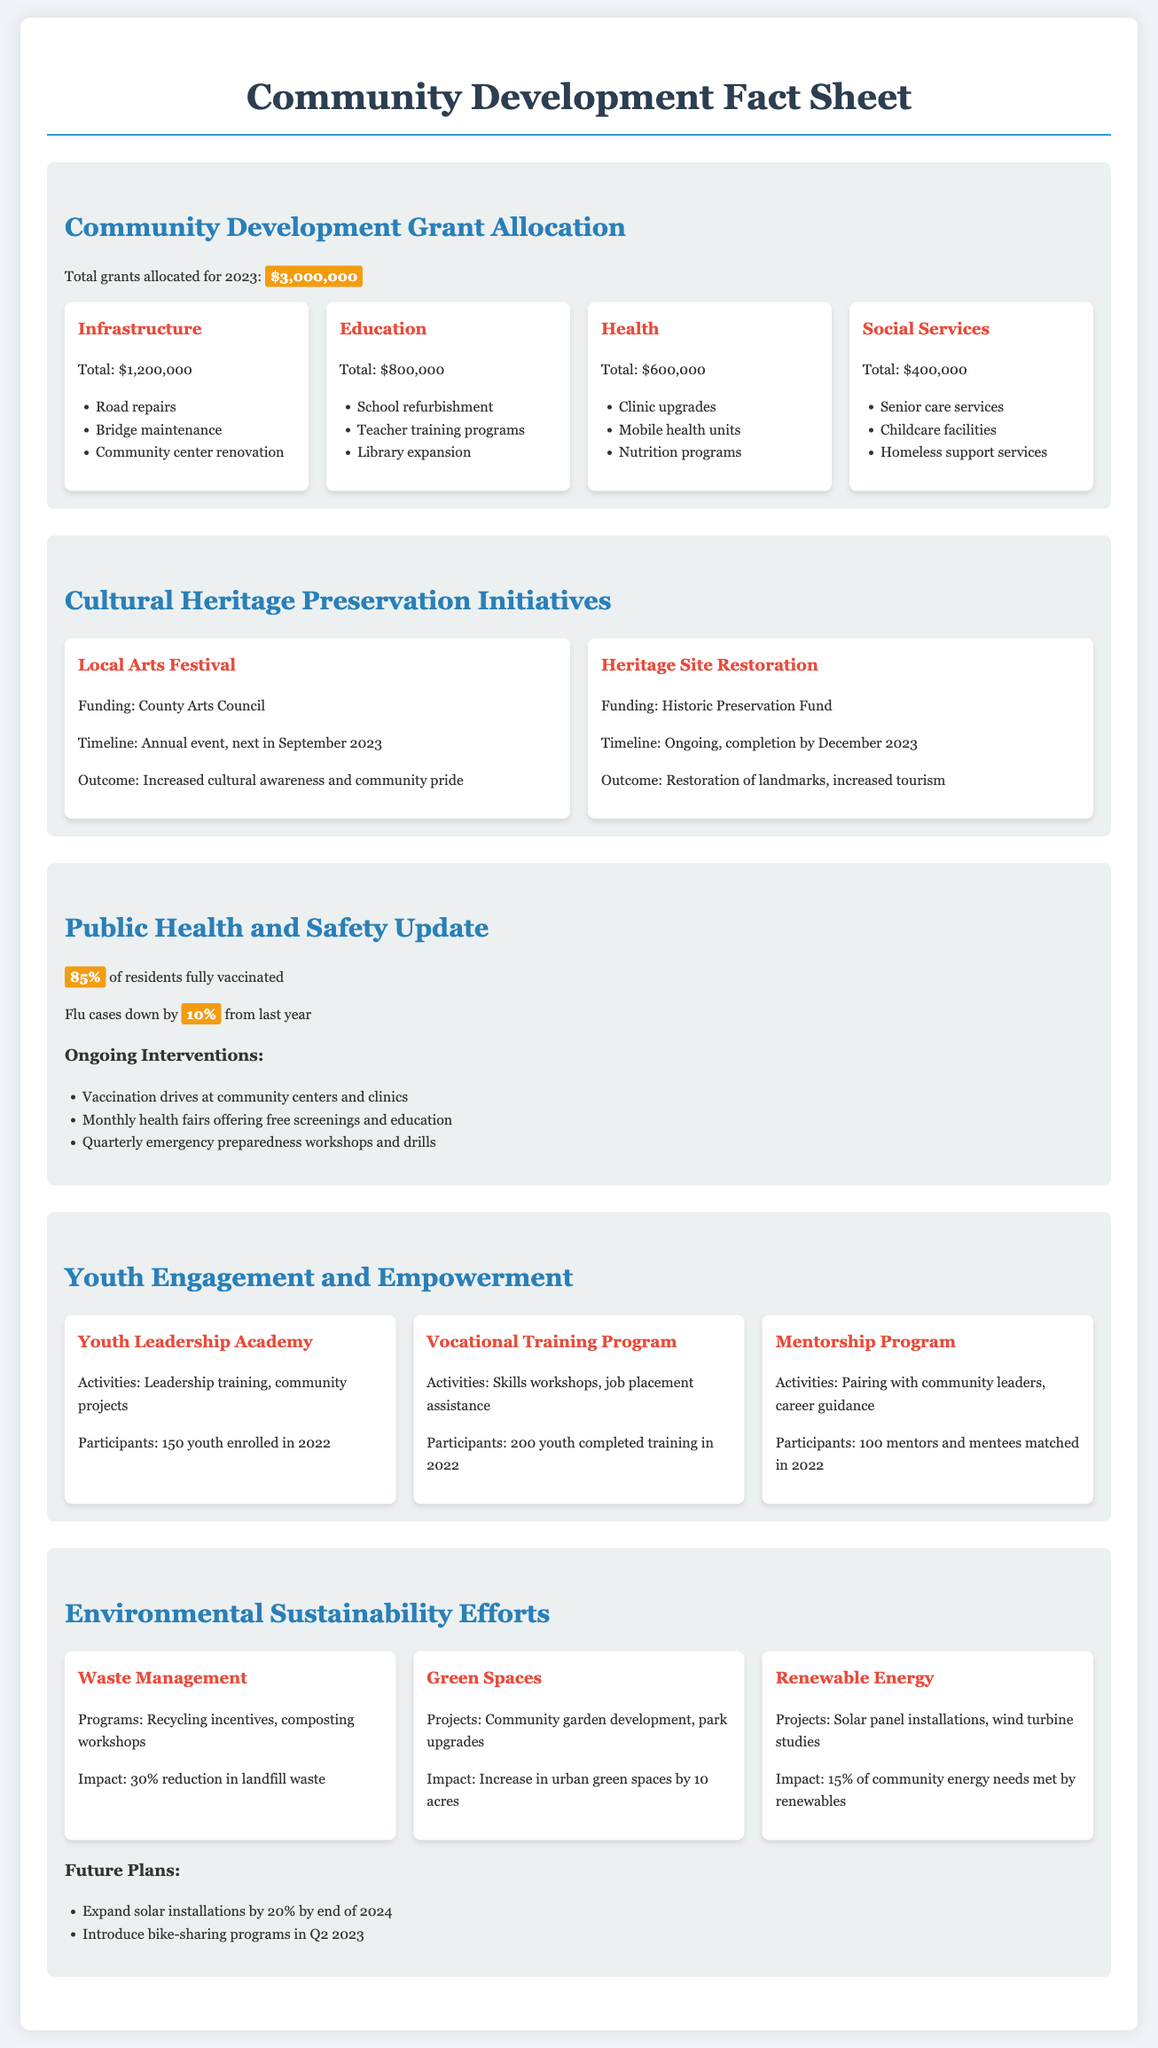What is the total amount of community development grants allocated for 2023? The document states that the total grants allocated for 2023 is $3,000,000.
Answer: $3,000,000 How much funding is allocated for infrastructure projects? According to the fact sheet, $1,200,000 is allocated for infrastructure projects.
Answer: $1,200,000 What percentage of residents are fully vaccinated? The document mentions that 85% of residents are fully vaccinated.
Answer: 85% What is the expected outcome of the Local Arts Festival? The expected outcome of the Local Arts Festival is increased cultural awareness and community pride.
Answer: Increased cultural awareness and community pride How many youth participants were enrolled in the Youth Leadership Academy in 2022? The document states that there were 150 youth enrolled in the Youth Leadership Academy in 2022.
Answer: 150 What is the impact of waste management programs? The impact mentioned in the document is a 30% reduction in landfill waste.
Answer: 30% reduction in landfill waste What is the timeline for the Heritage Site Restoration initiative? The timeline for the Heritage Site Restoration is ongoing, with completion by December 2023.
Answer: Ongoing, completion by December 2023 How many acres have urban green spaces increased by? The fact sheet states that urban green spaces have increased by 10 acres.
Answer: 10 acres What is the main focus of the Renewable Energy projects? The main focus is on solar panel installations and wind turbine studies.
Answer: Solar panel installations, wind turbine studies 